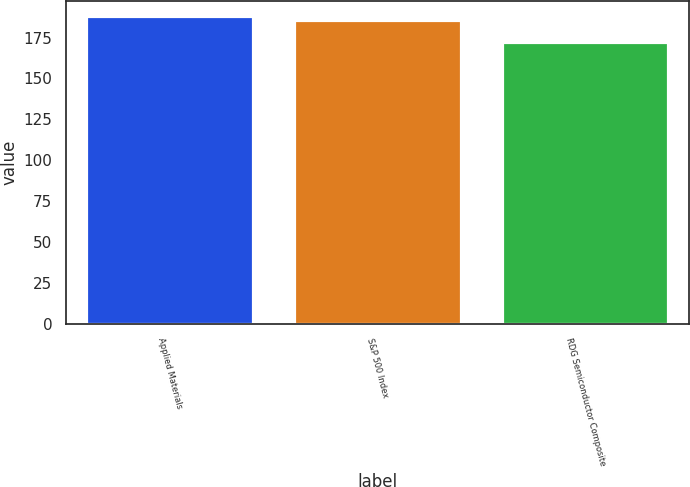<chart> <loc_0><loc_0><loc_500><loc_500><bar_chart><fcel>Applied Materials<fcel>S&P 500 Index<fcel>RDG Semiconductor Composite<nl><fcel>188.13<fcel>185.71<fcel>172.41<nl></chart> 